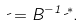Convert formula to latex. <formula><loc_0><loc_0><loc_500><loc_500>\psi = B ^ { - 1 } \psi ^ { * } .</formula> 